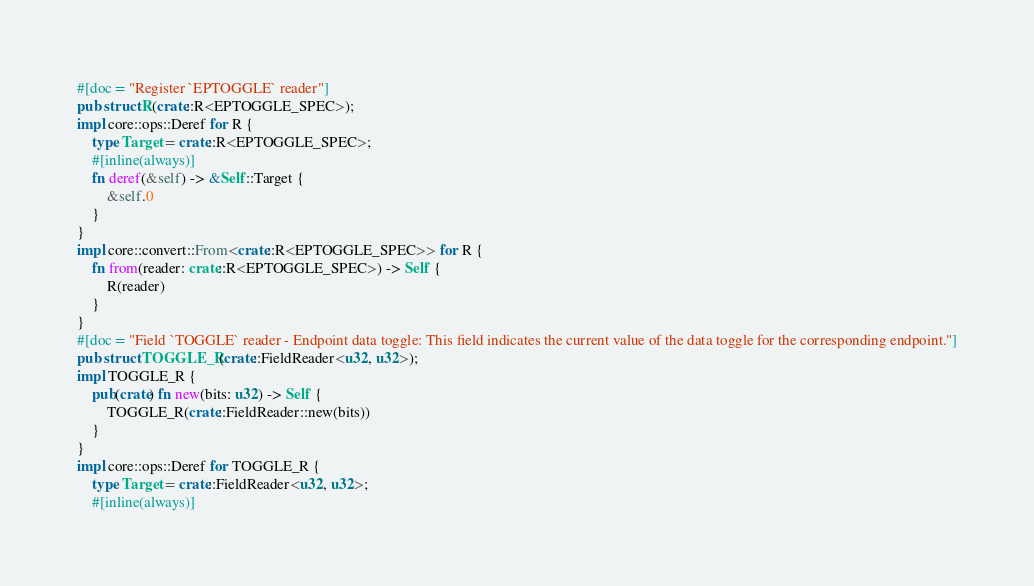<code> <loc_0><loc_0><loc_500><loc_500><_Rust_>#[doc = "Register `EPTOGGLE` reader"]
pub struct R(crate::R<EPTOGGLE_SPEC>);
impl core::ops::Deref for R {
    type Target = crate::R<EPTOGGLE_SPEC>;
    #[inline(always)]
    fn deref(&self) -> &Self::Target {
        &self.0
    }
}
impl core::convert::From<crate::R<EPTOGGLE_SPEC>> for R {
    fn from(reader: crate::R<EPTOGGLE_SPEC>) -> Self {
        R(reader)
    }
}
#[doc = "Field `TOGGLE` reader - Endpoint data toggle: This field indicates the current value of the data toggle for the corresponding endpoint."]
pub struct TOGGLE_R(crate::FieldReader<u32, u32>);
impl TOGGLE_R {
    pub(crate) fn new(bits: u32) -> Self {
        TOGGLE_R(crate::FieldReader::new(bits))
    }
}
impl core::ops::Deref for TOGGLE_R {
    type Target = crate::FieldReader<u32, u32>;
    #[inline(always)]</code> 